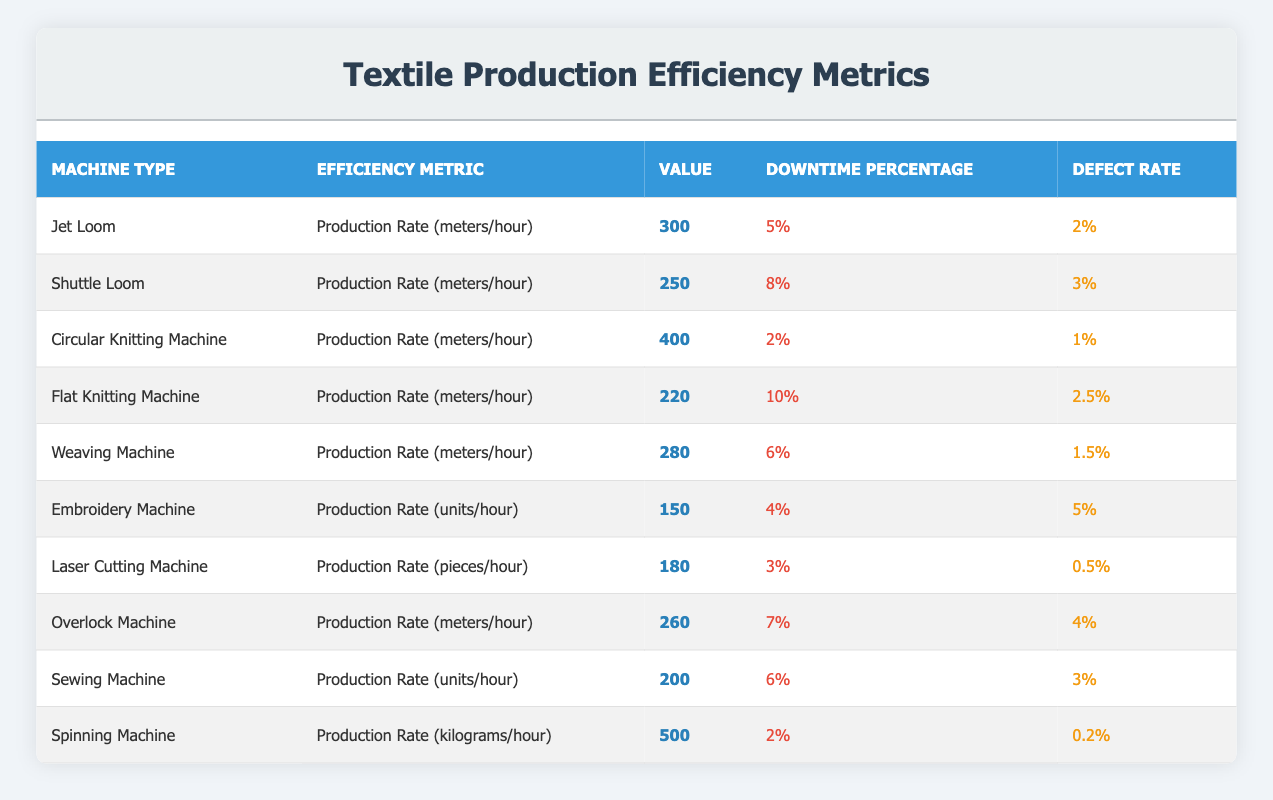What is the highest production rate among the machines? Looking at the "Value" column, the highest production rate is 500 from the Spinning Machine.
Answer: 500 Which machine has the lowest defect rate? The defect rates are listed, and the lowest is 0.2 from the Spinning Machine.
Answer: 0.2 Calculate the average downtime percentage across all machines. Summing the downtime percentages: (5 + 8 + 2 + 10 + 6 + 4 + 3 + 7 + 6 + 2) = 53. There are 10 machines, so the average is 53/10 = 5.3.
Answer: 5.3 Is the defect rate of the Jet Loom greater than that of the Circular Knitting Machine? The defect rate of the Jet Loom is 2% while that of the Circular Knitting Machine is 1%. Since 2% is greater than 1%, the statement is true.
Answer: Yes How much more efficient in production rate (in meters/hour) is the Circular Knitting Machine compared to the Flat Knitting Machine? The Circular Knitting Machine has a production rate of 400 meters/hour, and the Flat Knitting Machine has a production rate of 220 meters/hour. The difference is 400 - 220 = 180.
Answer: 180 Which machine has a downtime percentage of 6%? Referring to the downtime column, both the Weaving Machine and Sewing Machine have a downtime percentage of 6%.
Answer: Weaving Machine, Sewing Machine Does the Embroidery Machine have a higher defect rate than the Overlock Machine? The defect rate of the Embroidery Machine is 5% and the Overlock Machine's defect rate is 4%. Since 5% is greater than 4%, the statement is true.
Answer: Yes What is the combined production rate of the Jet Loom and the Weaving Machine? The production rate of the Jet Loom is 300 meters/hour and the Weaving Machine is 280 meters/hour. Adding them together gives 300 + 280 = 580.
Answer: 580 Which type of machine has the second lowest efficiency metric value and what is that value? Reviewing the "Value" column, the second lowest efficiency metric value is 250 from the Shuttle Loom.
Answer: 250 